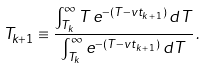Convert formula to latex. <formula><loc_0><loc_0><loc_500><loc_500>T _ { k + 1 } \equiv \frac { \int _ { T _ { k } } ^ { \infty } T \, e ^ { - ( T - v t _ { k \, + \, 1 } ) } \, d T } { \int _ { T _ { k } } ^ { \infty } e ^ { - ( T - v t _ { k \, + \, 1 } ) } \, d T } \, .</formula> 